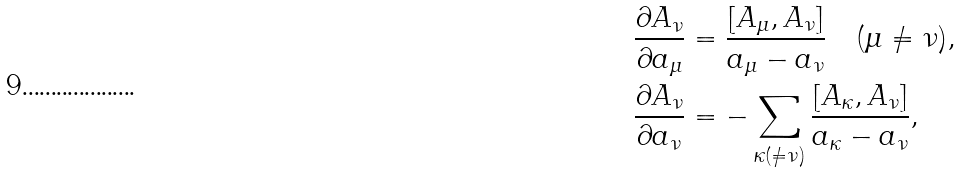<formula> <loc_0><loc_0><loc_500><loc_500>\frac { \partial A _ { \nu } } { \partial a _ { \mu } } & = \frac { [ A _ { \mu } , A _ { \nu } ] } { a _ { \mu } - a _ { \nu } } \quad ( \mu \ne \nu ) , \\ \frac { \partial A _ { \nu } } { \partial a _ { \nu } } & = - \sum _ { \kappa ( \ne \nu ) } \frac { [ A _ { \kappa } , A _ { \nu } ] } { a _ { \kappa } - a _ { \nu } } ,</formula> 